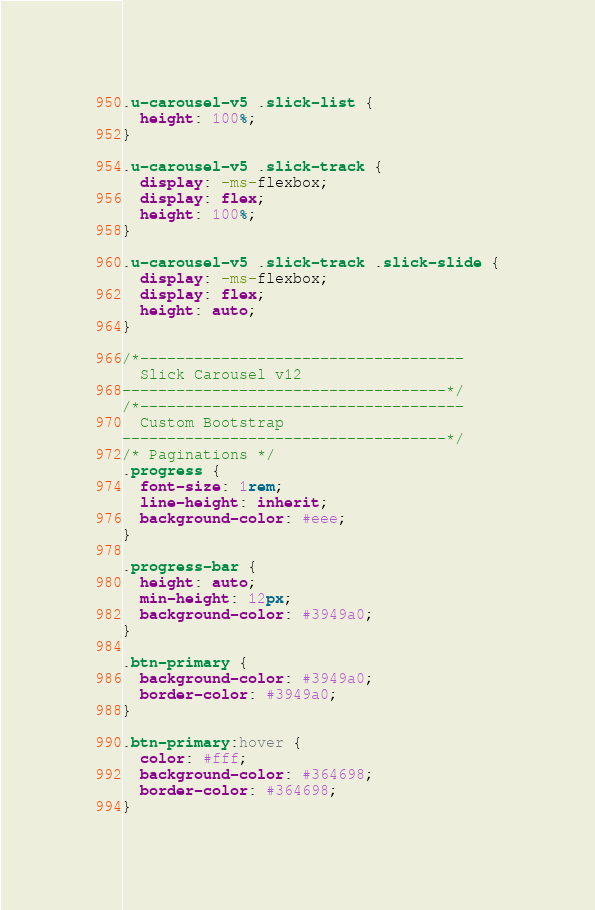<code> <loc_0><loc_0><loc_500><loc_500><_CSS_>.u-carousel-v5 .slick-list {
  height: 100%;
}

.u-carousel-v5 .slick-track {
  display: -ms-flexbox;
  display: flex;
  height: 100%;
}

.u-carousel-v5 .slick-track .slick-slide {
  display: -ms-flexbox;
  display: flex;
  height: auto;
}

/*------------------------------------
  Slick Carousel v12
------------------------------------*/
/*------------------------------------
  Custom Bootstrap
------------------------------------*/
/* Paginations */
.progress {
  font-size: 1rem;
  line-height: inherit;
  background-color: #eee;
}

.progress-bar {
  height: auto;
  min-height: 12px;
  background-color: #3949a0;
}

.btn-primary {
  background-color: #3949a0;
  border-color: #3949a0;
}

.btn-primary:hover {
  color: #fff;
  background-color: #364698;
  border-color: #364698;
}
</code> 